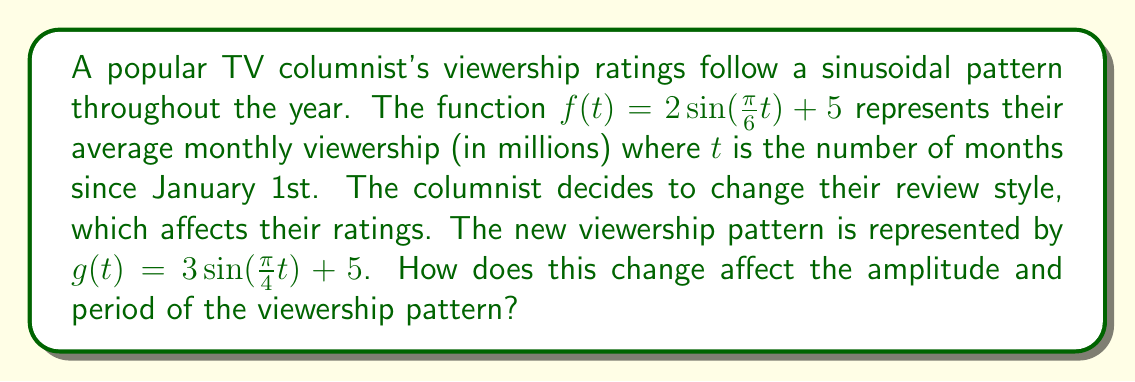Could you help me with this problem? To analyze the effect of parameter changes on a sinusoidal function's amplitude and period, let's compare the two functions:

1. Original function: $f(t) = 2\sin(\frac{\pi}{6}t) + 5$
2. New function: $g(t) = 3\sin(\frac{\pi}{4}t) + 5$

The general form of a sinusoidal function is:

$$A\sin(B(t-C)) + D$$

Where:
- $A$ is the amplitude
- $B$ affects the period (period = $\frac{2\pi}{|B|}$)
- $C$ is the phase shift
- $D$ is the vertical shift

For $f(t)$:
- Amplitude: $A = 2$
- Period: $\frac{2\pi}{|B|} = \frac{2\pi}{|\frac{\pi}{6}|} = 12$ months

For $g(t)$:
- Amplitude: $A = 3$
- Period: $\frac{2\pi}{|B|} = \frac{2\pi}{|\frac{\pi}{4}|} = 8$ months

Comparing the two functions:

1. Amplitude:
   - The amplitude increased from 2 to 3.
   - This means the range of viewership fluctuation increased by 1 million viewers.

2. Period:
   - The period decreased from 12 months to 8 months.
   - This indicates that the viewership cycle completes faster in the new pattern.
Answer: The change in the columnist's review style resulted in:
1. An increase in amplitude from 2 to 3, meaning the viewership fluctuation range increased by 1 million viewers.
2. A decrease in period from 12 months to 8 months, indicating a faster completion of the viewership cycle. 